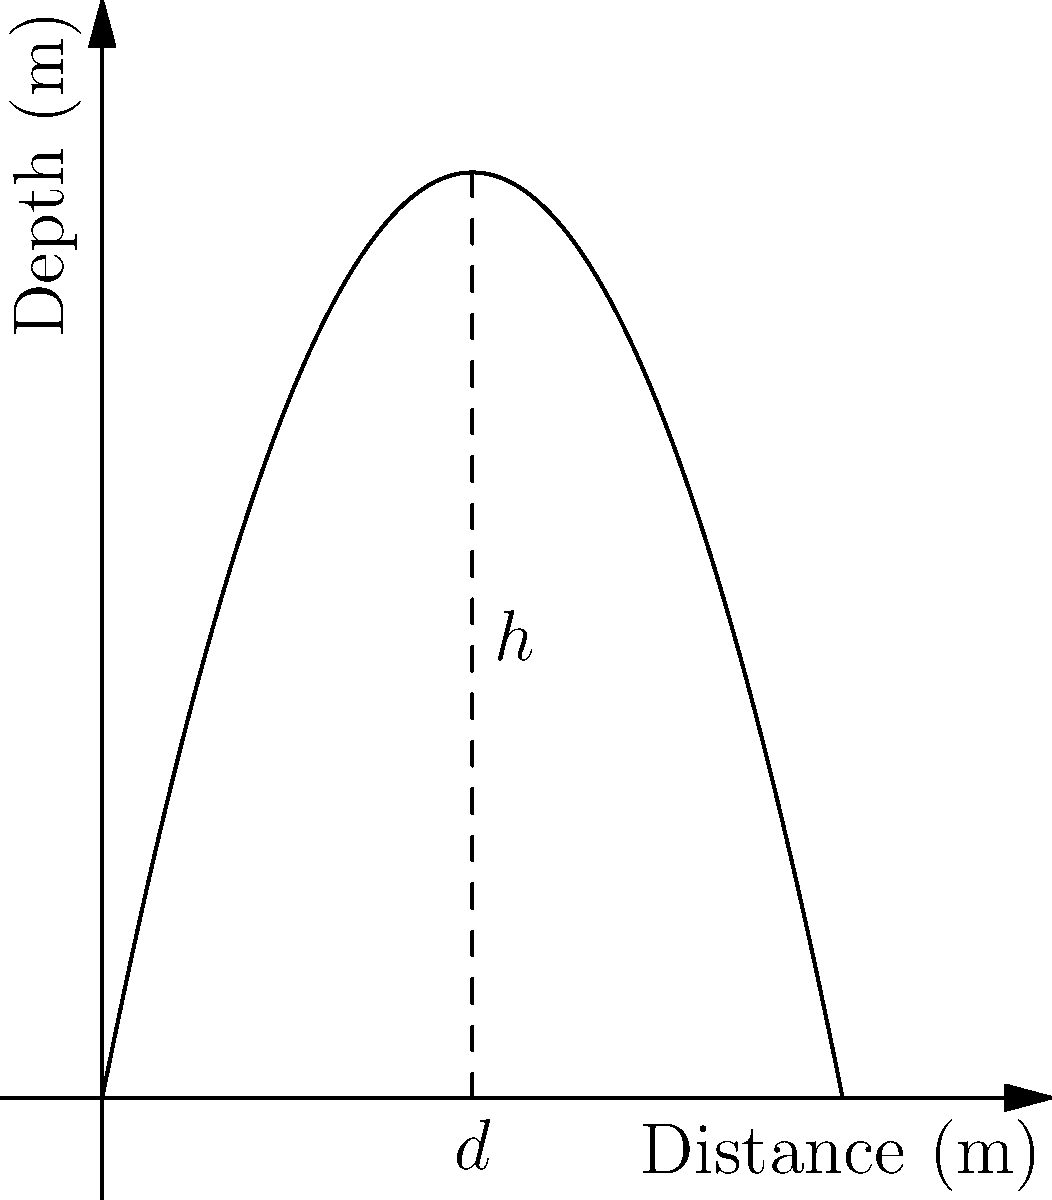A marine biologist is studying the diving behavior of a bottlenose dolphin. The dolphin's dive trajectory can be modeled by the parabolic function $f(x) = -0.5x^2 + 5x$, where $x$ represents the horizontal distance traveled in meters and $f(x)$ represents the depth in meters. What is the maximum depth reached by the dolphin during its dive, and at what horizontal distance does this occur? To find the maximum depth and its corresponding horizontal distance, we need to follow these steps:

1) The maximum point of a parabola occurs at the vertex. For a parabola in the form $f(x) = ax^2 + bx + c$, the x-coordinate of the vertex is given by $x = -\frac{b}{2a}$.

2) In our case, $a = -0.5$ and $b = 5$. Let's call the x-coordinate of the vertex $d$.

   $d = -\frac{5}{2(-0.5)} = \frac{5}{1} = 5$ meters

3) To find the maximum depth $h$, we substitute $x = 5$ into our original function:

   $h = f(5) = -0.5(5)^2 + 5(5) = -0.5(25) + 25 = -12.5 + 25 = 12.5$ meters

Therefore, the dolphin reaches its maximum depth of 12.5 meters at a horizontal distance of 5 meters from its starting point.
Answer: Maximum depth: 12.5 m; Horizontal distance: 5 m 